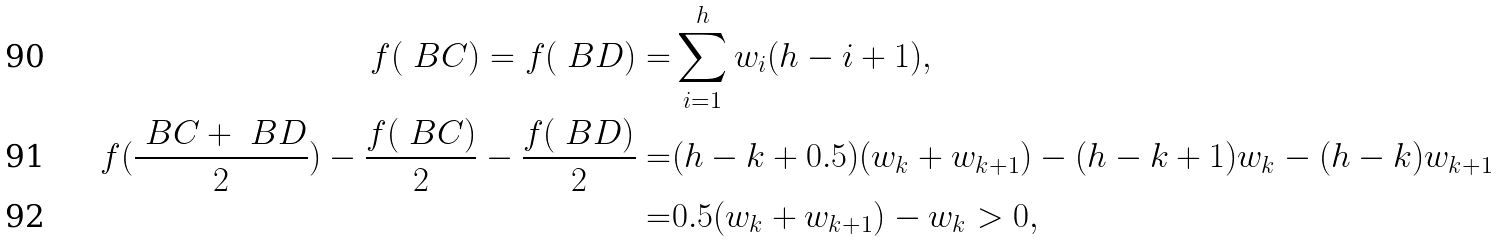Convert formula to latex. <formula><loc_0><loc_0><loc_500><loc_500>f ( \ B { C } ) = f ( \ B { D } ) = & \sum _ { i = 1 } ^ { h } w _ { i } ( h - i + 1 ) , \\ f ( \frac { \ B { C } + \ B { D } } { 2 } ) - \frac { f ( \ B { C } ) } { 2 } - \frac { f ( \ B { D } ) } { 2 } = & ( h - k + 0 . 5 ) ( w _ { k } + w _ { k + 1 } ) - ( h - k + 1 ) w _ { k } - ( h - k ) w _ { k + 1 } \\ = & 0 . 5 ( w _ { k } + w _ { k + 1 } ) - w _ { k } > 0 ,</formula> 